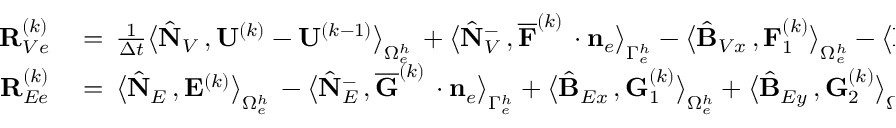<formula> <loc_0><loc_0><loc_500><loc_500>\begin{array} { r l } { { R } _ { V e } ^ { ( k ) } } & = \, \frac { 1 } { \Delta t } \left \langle \hat { N } _ { V } \, , { U } ^ { ( k ) } - { U } ^ { ( k - 1 ) } \right \rangle _ { \Omega _ { e } ^ { h } } \, + \left \langle \hat { N } _ { V } ^ { - } \, , \overline { F } ^ { ( k ) } \, \cdot { n } _ { e } \right \rangle _ { \Gamma _ { e } ^ { h } } - \left \langle \hat { B } _ { V x } \, , { F } _ { 1 } ^ { ( k ) } \right \rangle _ { \Omega _ { e } ^ { h } } - \left \langle \hat { B } _ { V y } \, , { F } _ { 2 } ^ { ( k ) } \right \rangle _ { \Omega _ { e } ^ { h } } } \\ { { R } _ { E e } ^ { ( k ) } } & = \, \left \langle \hat { N } _ { E } \, , { E } ^ { ( k ) } \right \rangle _ { \Omega _ { e } ^ { h } } \, - \left \langle \hat { N } _ { E } ^ { - } \, , \overline { G } ^ { ( k ) } \, \cdot { n } _ { e } \right \rangle _ { \Gamma _ { e } ^ { h } } + \left \langle \hat { B } _ { E x } \, , { G } _ { 1 } ^ { ( k ) } \right \rangle _ { \Omega _ { e } ^ { h } } + \left \langle \hat { B } _ { E y } \, , { G } _ { 2 } ^ { ( k ) } \right \rangle _ { \Omega _ { e } ^ { h } } = { 0 } \, , } \end{array}</formula> 